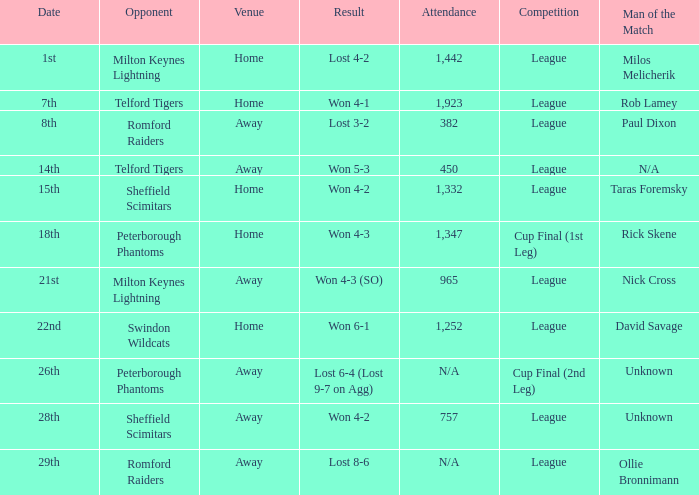On which date did the event take place at the location away, and the outcome was a 6-4 defeat (9-7 loss on aggregate)? 26th. 